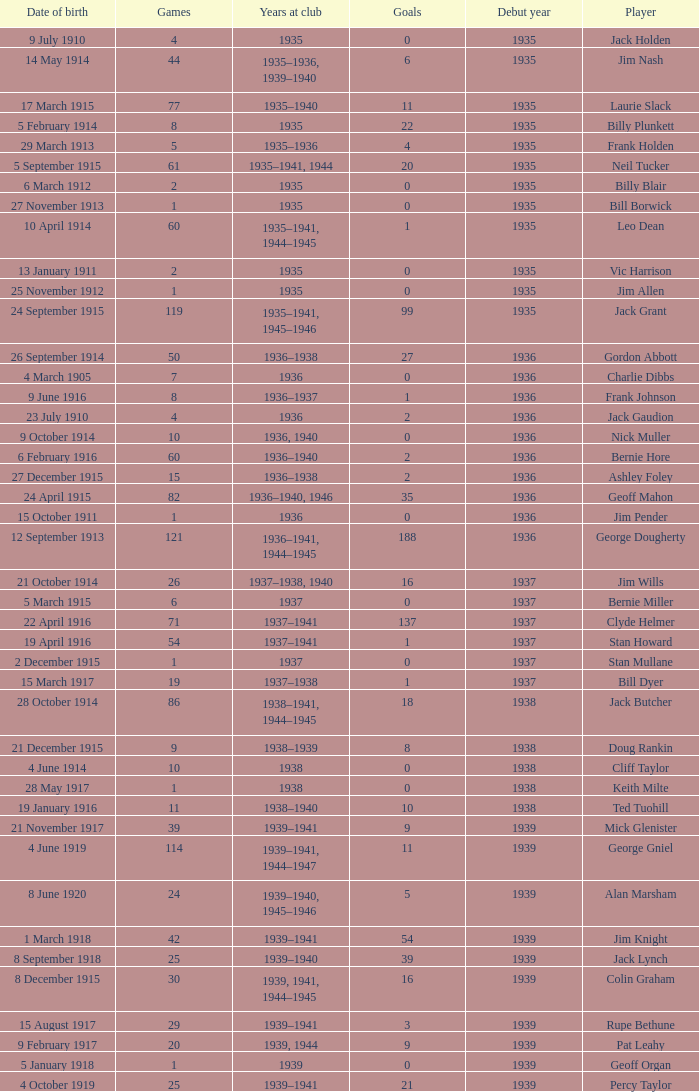What is the years at the club of the player with 2 goals and was born on 23 July 1910? 1936.0. 